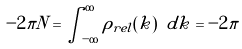Convert formula to latex. <formula><loc_0><loc_0><loc_500><loc_500>- 2 \pi N = \int _ { - \infty } ^ { \infty } \rho _ { r e l } ( k ) \ d k = - 2 \pi</formula> 